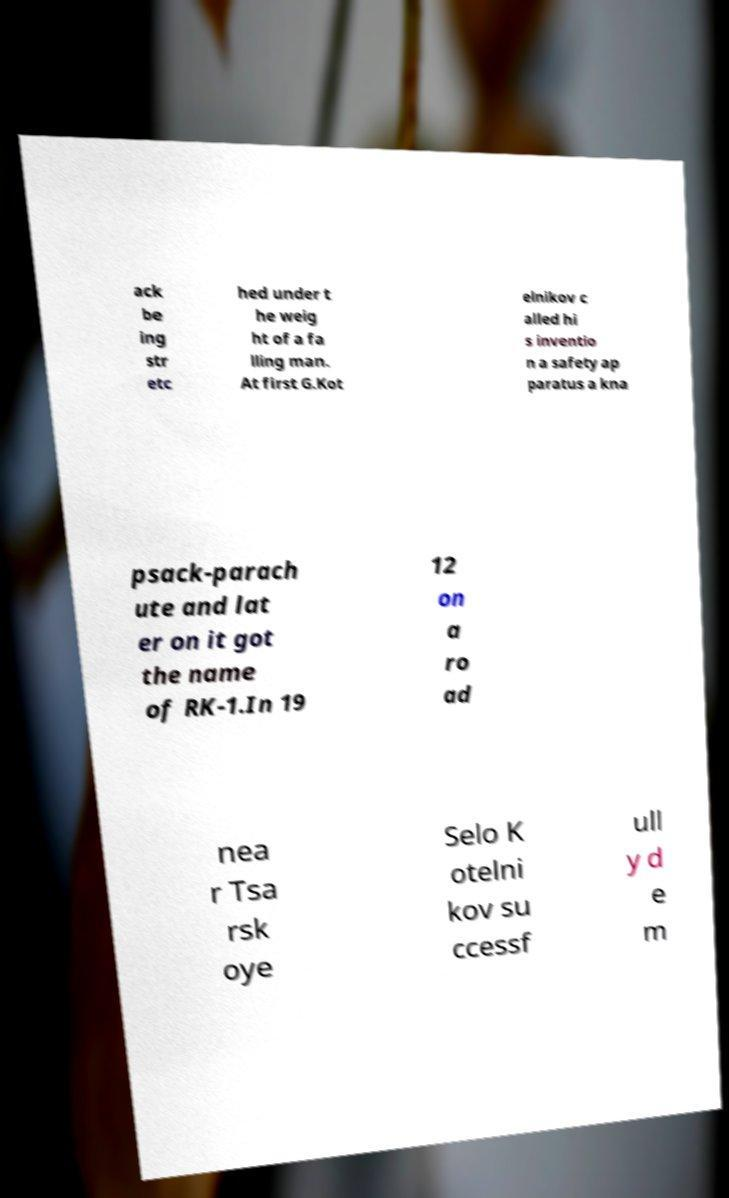For documentation purposes, I need the text within this image transcribed. Could you provide that? ack be ing str etc hed under t he weig ht of a fa lling man. At first G.Kot elnikov c alled hi s inventio n a safety ap paratus a kna psack-parach ute and lat er on it got the name of RK-1.In 19 12 on a ro ad nea r Tsa rsk oye Selo K otelni kov su ccessf ull y d e m 